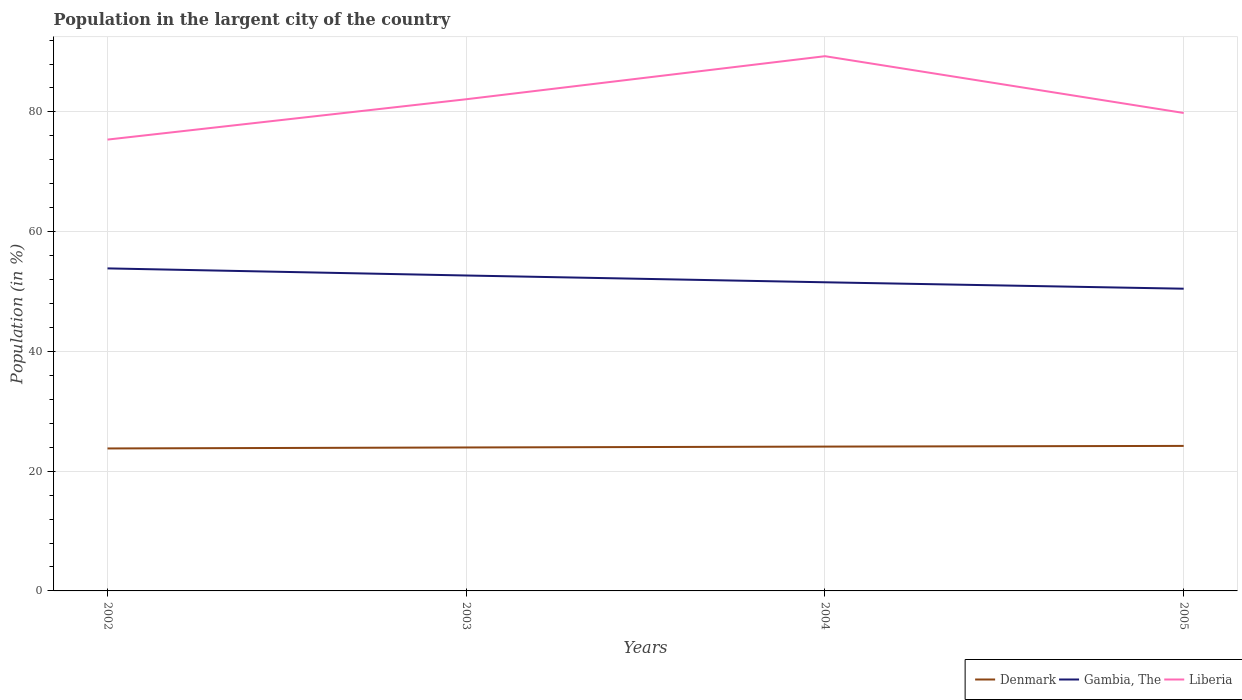Across all years, what is the maximum percentage of population in the largent city in Liberia?
Your answer should be very brief. 75.38. In which year was the percentage of population in the largent city in Liberia maximum?
Offer a very short reply. 2002. What is the total percentage of population in the largent city in Denmark in the graph?
Give a very brief answer. -0.31. What is the difference between the highest and the second highest percentage of population in the largent city in Liberia?
Provide a succinct answer. 13.93. What is the difference between the highest and the lowest percentage of population in the largent city in Liberia?
Give a very brief answer. 2. Is the percentage of population in the largent city in Denmark strictly greater than the percentage of population in the largent city in Liberia over the years?
Make the answer very short. Yes. Does the graph contain any zero values?
Ensure brevity in your answer.  No. Does the graph contain grids?
Offer a very short reply. Yes. What is the title of the graph?
Keep it short and to the point. Population in the largent city of the country. Does "Russian Federation" appear as one of the legend labels in the graph?
Your response must be concise. No. What is the Population (in %) of Denmark in 2002?
Keep it short and to the point. 23.79. What is the Population (in %) in Gambia, The in 2002?
Ensure brevity in your answer.  53.87. What is the Population (in %) in Liberia in 2002?
Provide a short and direct response. 75.38. What is the Population (in %) of Denmark in 2003?
Provide a succinct answer. 23.96. What is the Population (in %) of Gambia, The in 2003?
Offer a terse response. 52.68. What is the Population (in %) in Liberia in 2003?
Make the answer very short. 82.12. What is the Population (in %) in Denmark in 2004?
Keep it short and to the point. 24.11. What is the Population (in %) of Gambia, The in 2004?
Keep it short and to the point. 51.55. What is the Population (in %) of Liberia in 2004?
Offer a very short reply. 89.31. What is the Population (in %) in Denmark in 2005?
Keep it short and to the point. 24.22. What is the Population (in %) of Gambia, The in 2005?
Make the answer very short. 50.48. What is the Population (in %) in Liberia in 2005?
Your answer should be compact. 79.83. Across all years, what is the maximum Population (in %) of Denmark?
Make the answer very short. 24.22. Across all years, what is the maximum Population (in %) of Gambia, The?
Give a very brief answer. 53.87. Across all years, what is the maximum Population (in %) in Liberia?
Offer a terse response. 89.31. Across all years, what is the minimum Population (in %) of Denmark?
Offer a very short reply. 23.79. Across all years, what is the minimum Population (in %) of Gambia, The?
Give a very brief answer. 50.48. Across all years, what is the minimum Population (in %) in Liberia?
Your answer should be compact. 75.38. What is the total Population (in %) in Denmark in the graph?
Offer a very short reply. 96.08. What is the total Population (in %) of Gambia, The in the graph?
Make the answer very short. 208.58. What is the total Population (in %) in Liberia in the graph?
Your answer should be very brief. 326.65. What is the difference between the Population (in %) of Denmark in 2002 and that in 2003?
Keep it short and to the point. -0.17. What is the difference between the Population (in %) of Gambia, The in 2002 and that in 2003?
Your answer should be compact. 1.19. What is the difference between the Population (in %) of Liberia in 2002 and that in 2003?
Make the answer very short. -6.74. What is the difference between the Population (in %) of Denmark in 2002 and that in 2004?
Keep it short and to the point. -0.31. What is the difference between the Population (in %) in Gambia, The in 2002 and that in 2004?
Provide a short and direct response. 2.32. What is the difference between the Population (in %) in Liberia in 2002 and that in 2004?
Offer a terse response. -13.93. What is the difference between the Population (in %) in Denmark in 2002 and that in 2005?
Give a very brief answer. -0.43. What is the difference between the Population (in %) in Gambia, The in 2002 and that in 2005?
Give a very brief answer. 3.39. What is the difference between the Population (in %) of Liberia in 2002 and that in 2005?
Your answer should be compact. -4.44. What is the difference between the Population (in %) of Denmark in 2003 and that in 2004?
Make the answer very short. -0.14. What is the difference between the Population (in %) in Gambia, The in 2003 and that in 2004?
Ensure brevity in your answer.  1.13. What is the difference between the Population (in %) of Liberia in 2003 and that in 2004?
Ensure brevity in your answer.  -7.19. What is the difference between the Population (in %) in Denmark in 2003 and that in 2005?
Ensure brevity in your answer.  -0.26. What is the difference between the Population (in %) of Gambia, The in 2003 and that in 2005?
Your answer should be compact. 2.2. What is the difference between the Population (in %) in Liberia in 2003 and that in 2005?
Offer a terse response. 2.29. What is the difference between the Population (in %) of Denmark in 2004 and that in 2005?
Keep it short and to the point. -0.12. What is the difference between the Population (in %) of Gambia, The in 2004 and that in 2005?
Provide a succinct answer. 1.07. What is the difference between the Population (in %) in Liberia in 2004 and that in 2005?
Make the answer very short. 9.48. What is the difference between the Population (in %) of Denmark in 2002 and the Population (in %) of Gambia, The in 2003?
Ensure brevity in your answer.  -28.89. What is the difference between the Population (in %) in Denmark in 2002 and the Population (in %) in Liberia in 2003?
Provide a succinct answer. -58.33. What is the difference between the Population (in %) in Gambia, The in 2002 and the Population (in %) in Liberia in 2003?
Provide a succinct answer. -28.25. What is the difference between the Population (in %) in Denmark in 2002 and the Population (in %) in Gambia, The in 2004?
Offer a very short reply. -27.75. What is the difference between the Population (in %) of Denmark in 2002 and the Population (in %) of Liberia in 2004?
Your answer should be very brief. -65.52. What is the difference between the Population (in %) of Gambia, The in 2002 and the Population (in %) of Liberia in 2004?
Your answer should be compact. -35.44. What is the difference between the Population (in %) of Denmark in 2002 and the Population (in %) of Gambia, The in 2005?
Your answer should be compact. -26.68. What is the difference between the Population (in %) in Denmark in 2002 and the Population (in %) in Liberia in 2005?
Ensure brevity in your answer.  -56.03. What is the difference between the Population (in %) in Gambia, The in 2002 and the Population (in %) in Liberia in 2005?
Your answer should be compact. -25.96. What is the difference between the Population (in %) of Denmark in 2003 and the Population (in %) of Gambia, The in 2004?
Your answer should be very brief. -27.59. What is the difference between the Population (in %) of Denmark in 2003 and the Population (in %) of Liberia in 2004?
Keep it short and to the point. -65.35. What is the difference between the Population (in %) of Gambia, The in 2003 and the Population (in %) of Liberia in 2004?
Provide a short and direct response. -36.63. What is the difference between the Population (in %) of Denmark in 2003 and the Population (in %) of Gambia, The in 2005?
Make the answer very short. -26.52. What is the difference between the Population (in %) of Denmark in 2003 and the Population (in %) of Liberia in 2005?
Offer a very short reply. -55.87. What is the difference between the Population (in %) of Gambia, The in 2003 and the Population (in %) of Liberia in 2005?
Your answer should be very brief. -27.15. What is the difference between the Population (in %) in Denmark in 2004 and the Population (in %) in Gambia, The in 2005?
Your answer should be compact. -26.37. What is the difference between the Population (in %) in Denmark in 2004 and the Population (in %) in Liberia in 2005?
Offer a very short reply. -55.72. What is the difference between the Population (in %) of Gambia, The in 2004 and the Population (in %) of Liberia in 2005?
Keep it short and to the point. -28.28. What is the average Population (in %) in Denmark per year?
Keep it short and to the point. 24.02. What is the average Population (in %) in Gambia, The per year?
Keep it short and to the point. 52.14. What is the average Population (in %) in Liberia per year?
Your answer should be very brief. 81.66. In the year 2002, what is the difference between the Population (in %) in Denmark and Population (in %) in Gambia, The?
Make the answer very short. -30.08. In the year 2002, what is the difference between the Population (in %) in Denmark and Population (in %) in Liberia?
Your response must be concise. -51.59. In the year 2002, what is the difference between the Population (in %) of Gambia, The and Population (in %) of Liberia?
Your answer should be very brief. -21.51. In the year 2003, what is the difference between the Population (in %) in Denmark and Population (in %) in Gambia, The?
Make the answer very short. -28.72. In the year 2003, what is the difference between the Population (in %) of Denmark and Population (in %) of Liberia?
Your answer should be compact. -58.16. In the year 2003, what is the difference between the Population (in %) in Gambia, The and Population (in %) in Liberia?
Make the answer very short. -29.44. In the year 2004, what is the difference between the Population (in %) of Denmark and Population (in %) of Gambia, The?
Offer a very short reply. -27.44. In the year 2004, what is the difference between the Population (in %) of Denmark and Population (in %) of Liberia?
Offer a very short reply. -65.21. In the year 2004, what is the difference between the Population (in %) in Gambia, The and Population (in %) in Liberia?
Keep it short and to the point. -37.76. In the year 2005, what is the difference between the Population (in %) in Denmark and Population (in %) in Gambia, The?
Keep it short and to the point. -26.26. In the year 2005, what is the difference between the Population (in %) of Denmark and Population (in %) of Liberia?
Keep it short and to the point. -55.61. In the year 2005, what is the difference between the Population (in %) of Gambia, The and Population (in %) of Liberia?
Offer a very short reply. -29.35. What is the ratio of the Population (in %) of Gambia, The in 2002 to that in 2003?
Ensure brevity in your answer.  1.02. What is the ratio of the Population (in %) of Liberia in 2002 to that in 2003?
Make the answer very short. 0.92. What is the ratio of the Population (in %) in Denmark in 2002 to that in 2004?
Your response must be concise. 0.99. What is the ratio of the Population (in %) in Gambia, The in 2002 to that in 2004?
Your answer should be very brief. 1.04. What is the ratio of the Population (in %) in Liberia in 2002 to that in 2004?
Your response must be concise. 0.84. What is the ratio of the Population (in %) of Denmark in 2002 to that in 2005?
Make the answer very short. 0.98. What is the ratio of the Population (in %) of Gambia, The in 2002 to that in 2005?
Ensure brevity in your answer.  1.07. What is the ratio of the Population (in %) of Liberia in 2002 to that in 2005?
Give a very brief answer. 0.94. What is the ratio of the Population (in %) in Liberia in 2003 to that in 2004?
Make the answer very short. 0.92. What is the ratio of the Population (in %) of Denmark in 2003 to that in 2005?
Make the answer very short. 0.99. What is the ratio of the Population (in %) of Gambia, The in 2003 to that in 2005?
Ensure brevity in your answer.  1.04. What is the ratio of the Population (in %) of Liberia in 2003 to that in 2005?
Make the answer very short. 1.03. What is the ratio of the Population (in %) of Gambia, The in 2004 to that in 2005?
Provide a short and direct response. 1.02. What is the ratio of the Population (in %) in Liberia in 2004 to that in 2005?
Provide a succinct answer. 1.12. What is the difference between the highest and the second highest Population (in %) in Denmark?
Provide a short and direct response. 0.12. What is the difference between the highest and the second highest Population (in %) of Gambia, The?
Offer a very short reply. 1.19. What is the difference between the highest and the second highest Population (in %) of Liberia?
Give a very brief answer. 7.19. What is the difference between the highest and the lowest Population (in %) of Denmark?
Provide a succinct answer. 0.43. What is the difference between the highest and the lowest Population (in %) of Gambia, The?
Offer a terse response. 3.39. What is the difference between the highest and the lowest Population (in %) in Liberia?
Make the answer very short. 13.93. 